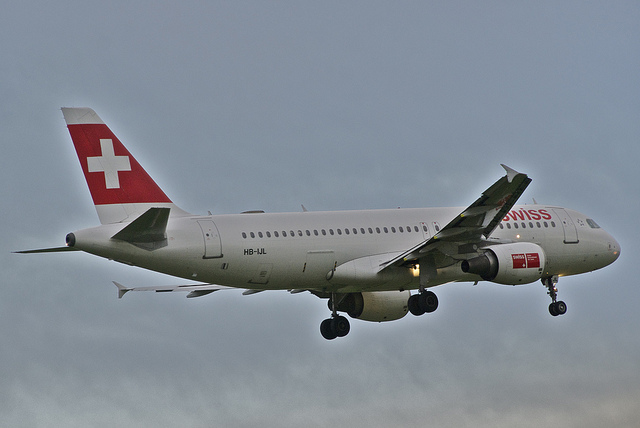Please identify all text content in this image. HB UL swiss 